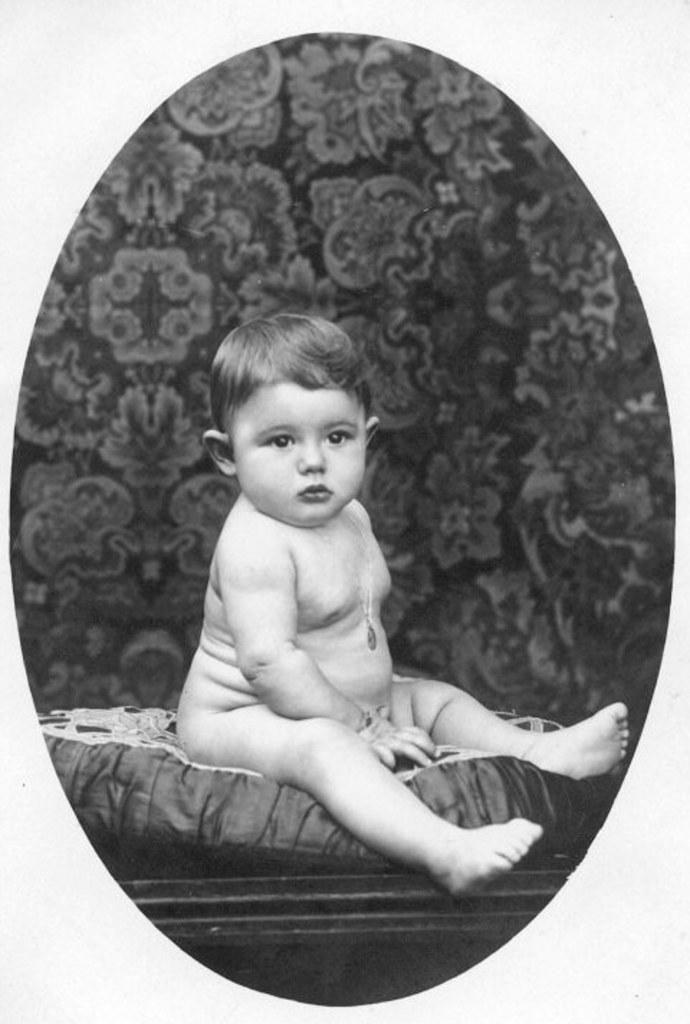What is the main subject of the image? There is a small baby in the image. What color scheme is used in the image? The image is black and white. How many things can be seen flying with a range of 500 miles in the image? There are no things flying with a range of 500 miles in the image, as it only features a small baby. 